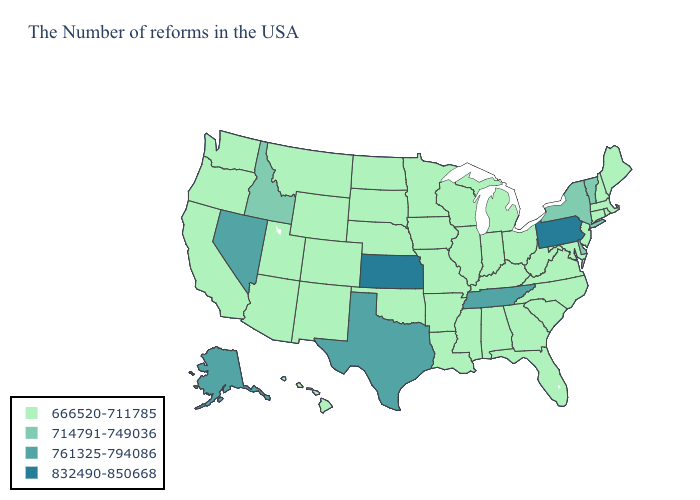Which states have the highest value in the USA?
Give a very brief answer. Pennsylvania, Kansas. Does Indiana have the lowest value in the USA?
Answer briefly. Yes. Name the states that have a value in the range 832490-850668?
Quick response, please. Pennsylvania, Kansas. Name the states that have a value in the range 832490-850668?
Give a very brief answer. Pennsylvania, Kansas. Among the states that border Massachusetts , which have the highest value?
Give a very brief answer. Vermont, New York. Name the states that have a value in the range 666520-711785?
Give a very brief answer. Maine, Massachusetts, Rhode Island, New Hampshire, Connecticut, New Jersey, Maryland, Virginia, North Carolina, South Carolina, West Virginia, Ohio, Florida, Georgia, Michigan, Kentucky, Indiana, Alabama, Wisconsin, Illinois, Mississippi, Louisiana, Missouri, Arkansas, Minnesota, Iowa, Nebraska, Oklahoma, South Dakota, North Dakota, Wyoming, Colorado, New Mexico, Utah, Montana, Arizona, California, Washington, Oregon, Hawaii. Name the states that have a value in the range 832490-850668?
Concise answer only. Pennsylvania, Kansas. What is the value of Louisiana?
Keep it brief. 666520-711785. Name the states that have a value in the range 714791-749036?
Short answer required. Vermont, New York, Delaware, Idaho. What is the value of Kentucky?
Short answer required. 666520-711785. Name the states that have a value in the range 832490-850668?
Keep it brief. Pennsylvania, Kansas. Name the states that have a value in the range 714791-749036?
Write a very short answer. Vermont, New York, Delaware, Idaho. What is the highest value in states that border New Jersey?
Answer briefly. 832490-850668. 